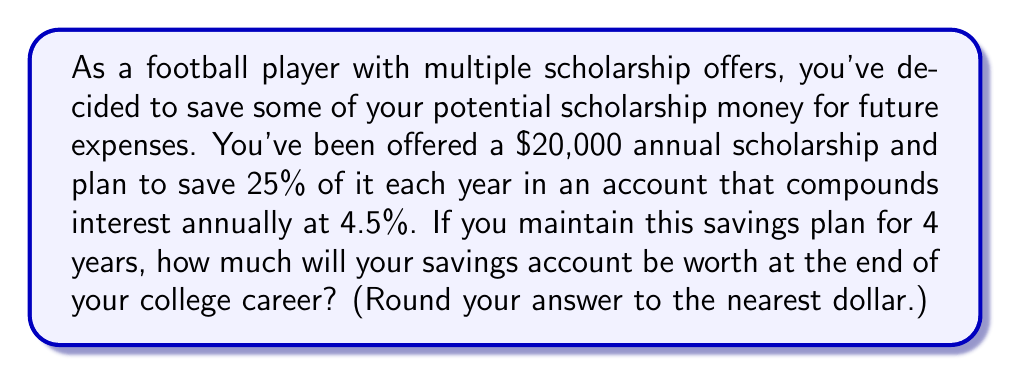Provide a solution to this math problem. Let's break this down step-by-step:

1) First, calculate the amount you'll save each year:
   $20,000 \times 25\% = $5,000$ per year

2) We'll use the compound interest formula:
   $A = P(1 + r)^n$
   Where:
   $A$ = final amount
   $P$ = principal (initial investment)
   $r$ = annual interest rate (as a decimal)
   $n$ = number of years

3) In this case, we're making deposits each year, so we need to calculate the value of each year's deposit separately:

   Year 1: $5000(1 + 0.045)^4$
   Year 2: $5000(1 + 0.045)^3$
   Year 3: $5000(1 + 0.045)^2$
   Year 4: $5000(1 + 0.045)^1$

4) Let's calculate each:
   Year 1: $5000(1.045)^4 = 5000 \times 1.1925 = 5962.50$
   Year 2: $5000(1.045)^3 = 5000 \times 1.1411 = 5705.75$
   Year 3: $5000(1.045)^2 = 5000 \times 1.0920 = 5460.00$
   Year 4: $5000(1.045)^1 = 5000 \times 1.0450 = 5225.00$

5) Now, sum all these values:
   $5962.50 + 5705.75 + 5460.00 + 5225.00 = 22353.25$

6) Rounding to the nearest dollar gives us $22,353.
Answer: $22,353 